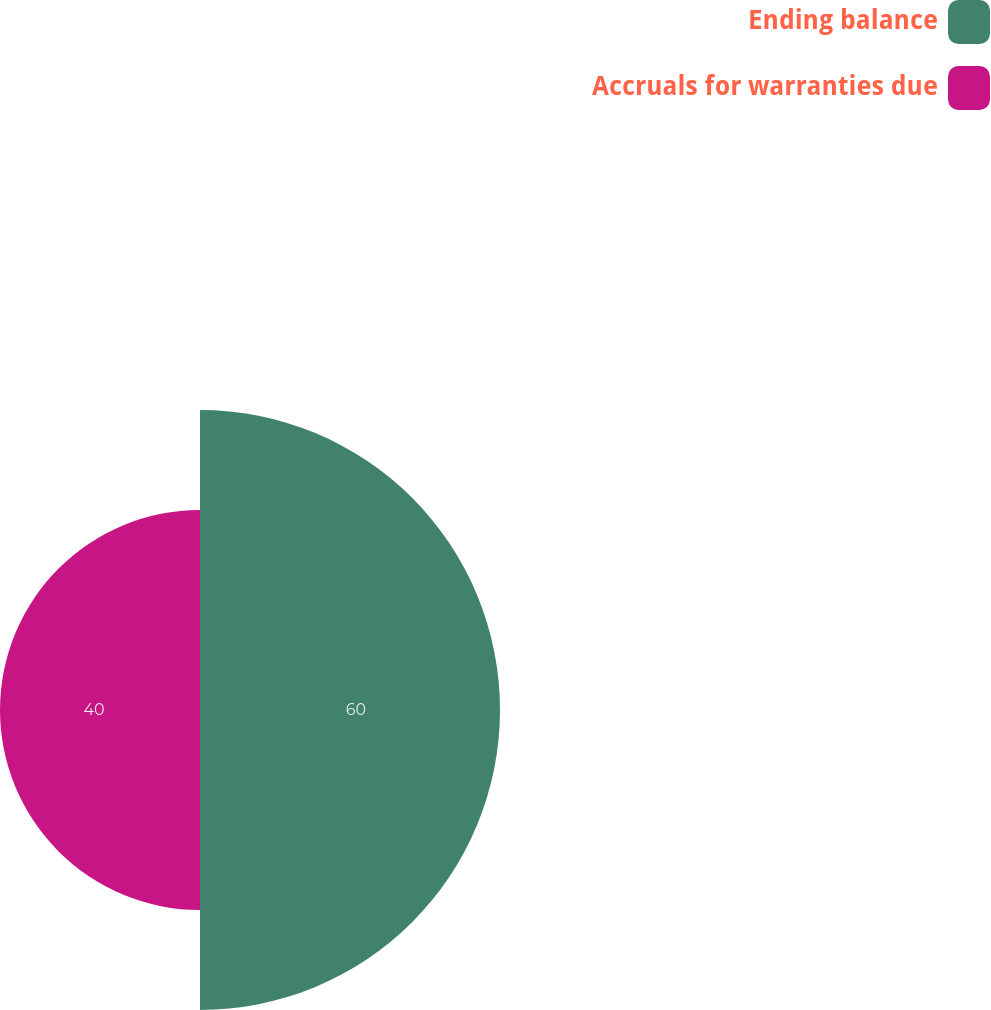<chart> <loc_0><loc_0><loc_500><loc_500><pie_chart><fcel>Ending balance<fcel>Accruals for warranties due<nl><fcel>60.0%<fcel>40.0%<nl></chart> 